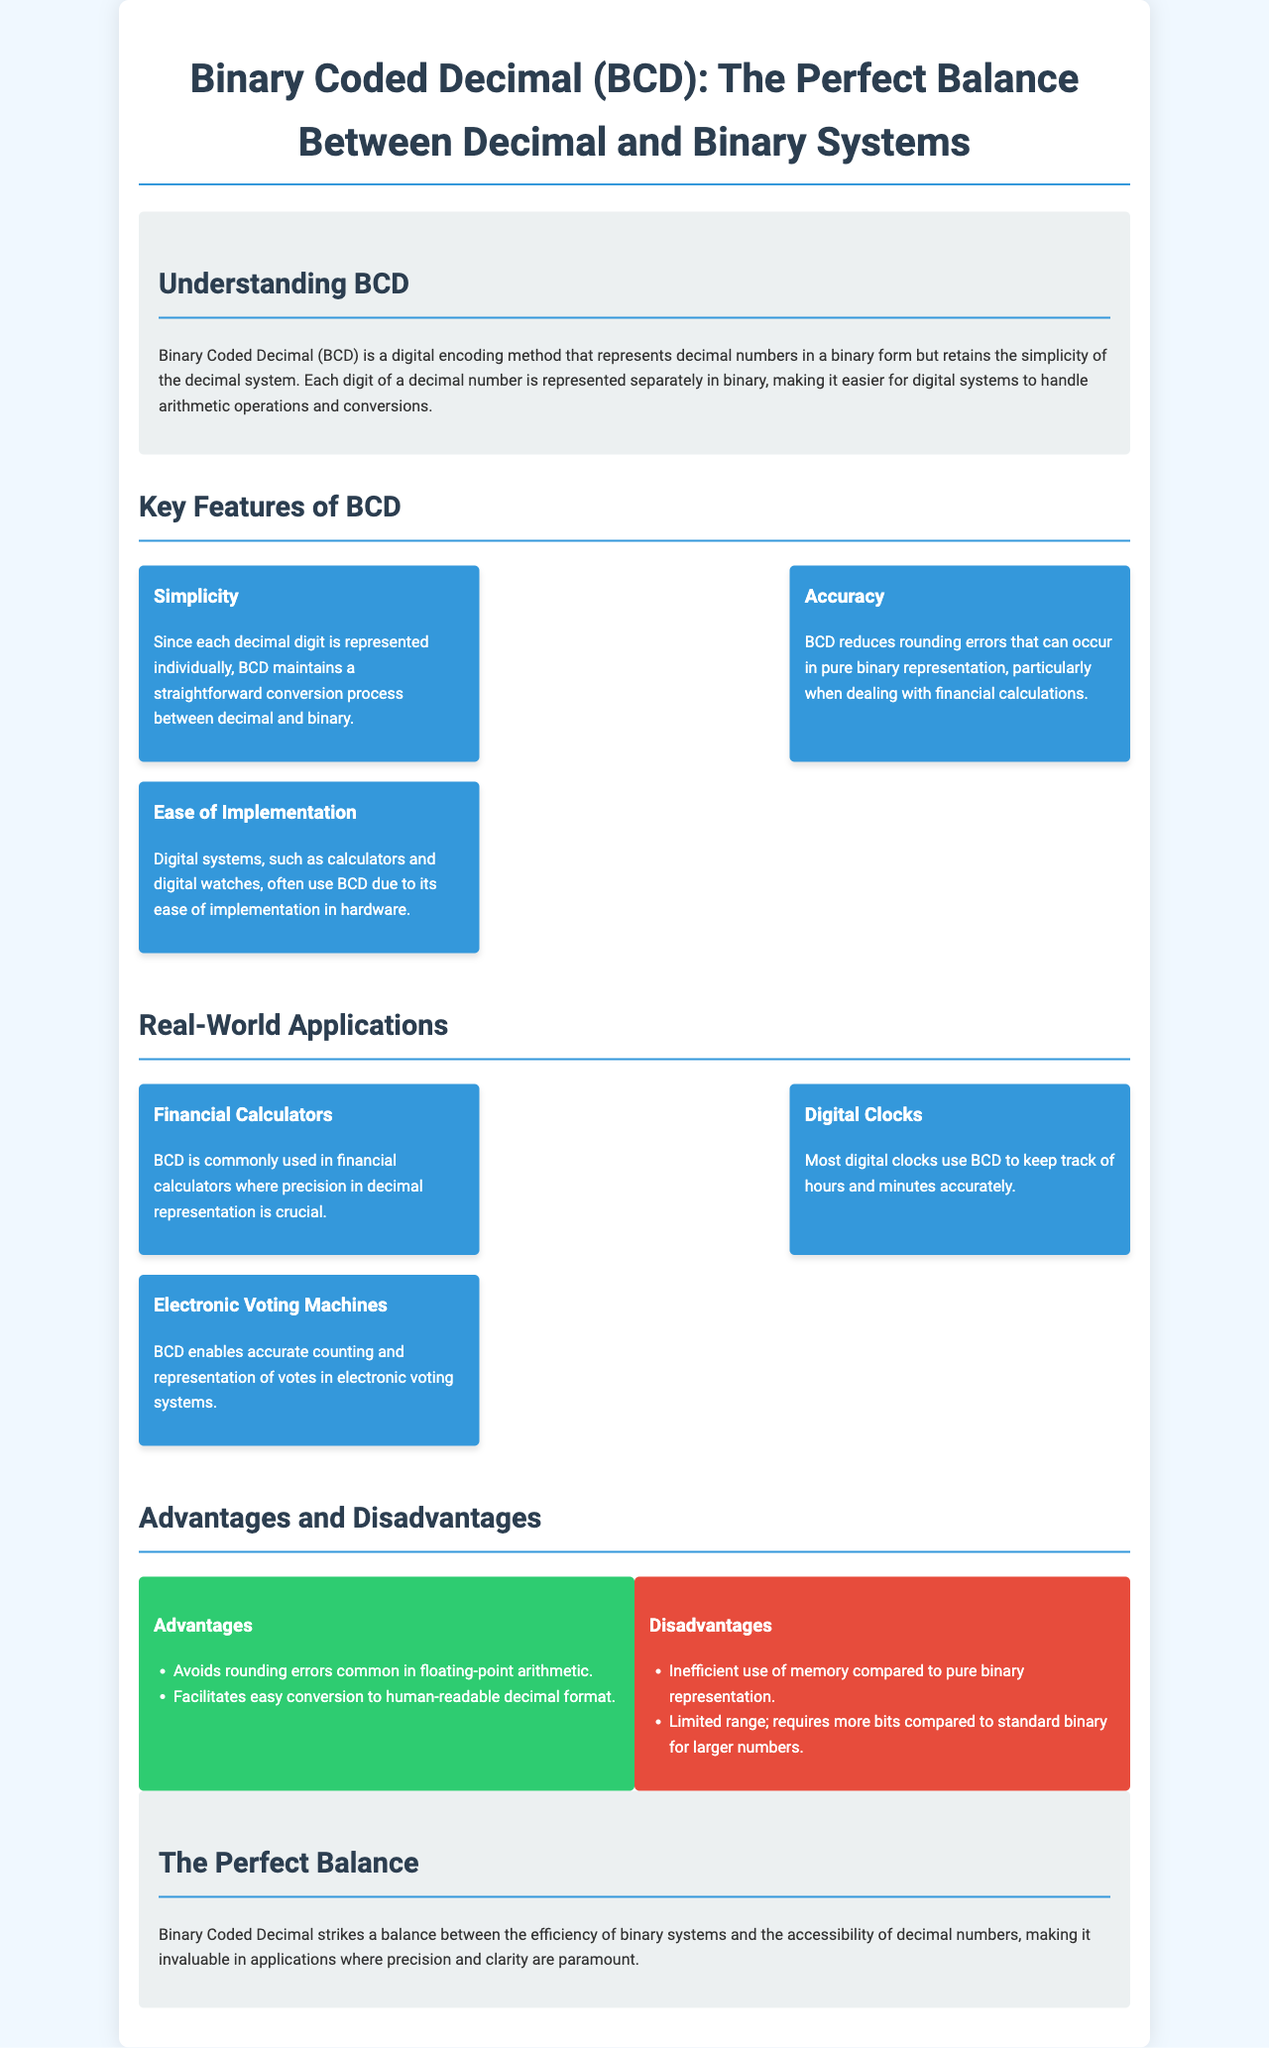What does BCD stand for? BCD stands for Binary Coded Decimal, as mentioned in the introduction of the document.
Answer: Binary Coded Decimal How many key features of BCD are listed? There are three key features of BCD mentioned in the document under the Key Features section.
Answer: Three What application uses BCD for accurate counting? The application that uses BCD for accurate counting is mentioned under Real-World Applications in relation to electronic systems.
Answer: Electronic Voting Machines What is the primary advantage of BCD? The primary advantage mentioned is that BCD avoids rounding errors common in floating-point arithmetic, as stated in the Advantages section.
Answer: Avoids rounding errors What is one disadvantage of using BCD? One disadvantage listed is its inefficient use of memory compared to pure binary representation, as clarified in the Disadvantages section.
Answer: Inefficient use of memory What type of clocks use BCD? The document mentions that most digital clocks use BCD under the Real-World Applications section.
Answer: Digital Clocks What is the background color of the document? The background color of the body of the document is specified within the style, as a soft color to facilitate readability.
Answer: Light blue How does BCD help in financial calculations? BCD reduces rounding errors that can occur during financial calculations, specifically highlighted under Accuracy in Key Features.
Answer: Reduces rounding errors 